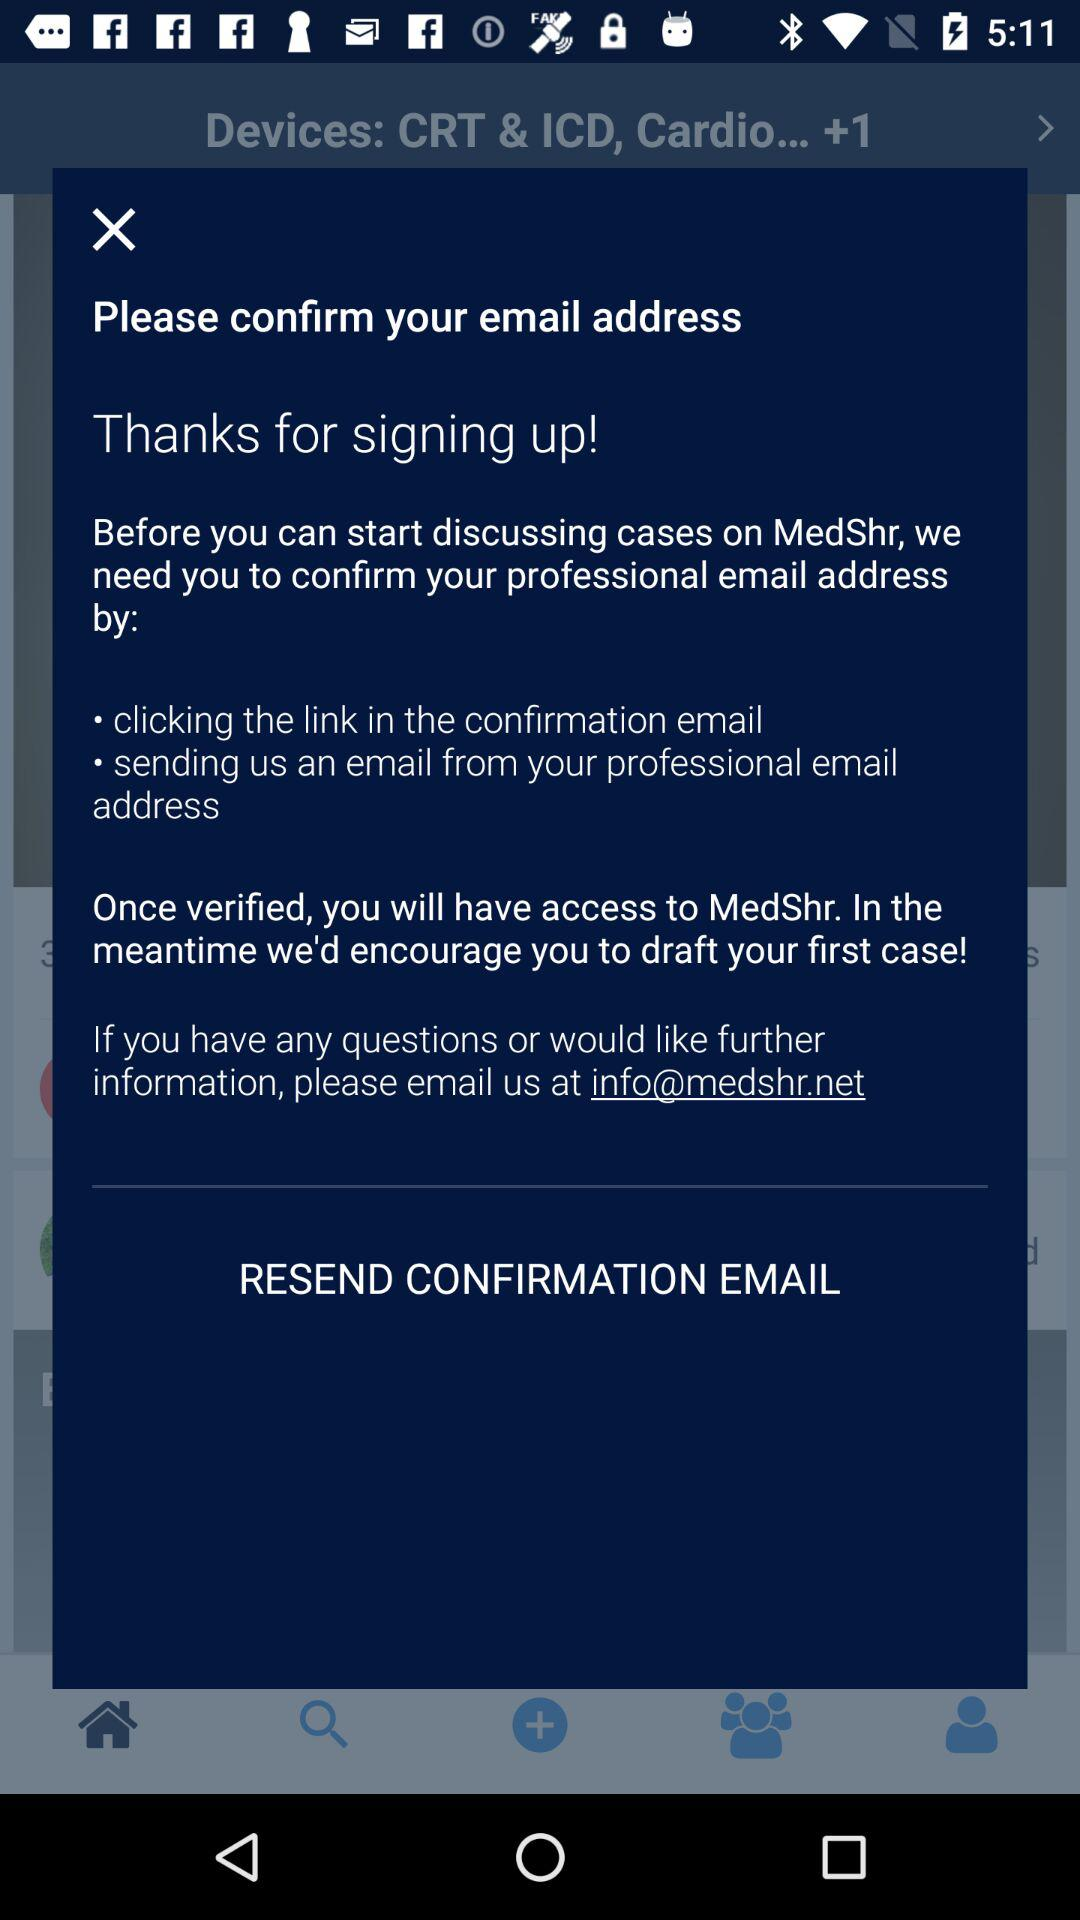How many ways can I confirm my email address?
Answer the question using a single word or phrase. 2 